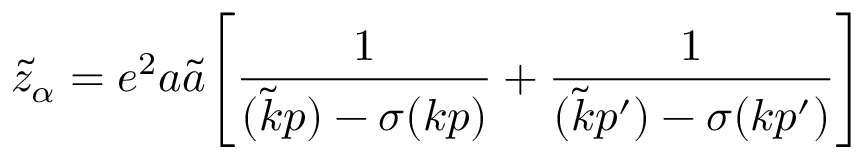<formula> <loc_0><loc_0><loc_500><loc_500>\tilde { z } _ { \alpha } = e ^ { 2 } a \tilde { a } \left [ \frac { 1 } { ( \tilde { k } p ) - \sigma ( k p ) } + \frac { 1 } { ( \tilde { k } p ^ { \prime } ) - \sigma ( k p ^ { \prime } ) } \right ]</formula> 